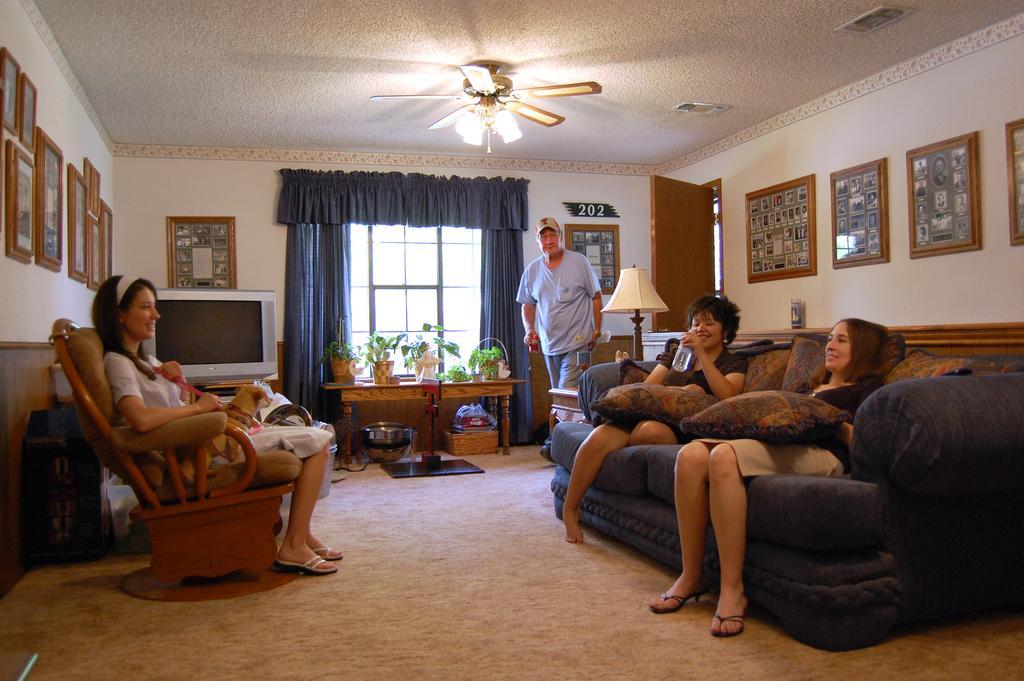How would you summarize this image in a sentence or two? As we can see in the image there is a white color wall, photo frames, fan, window, curtain and a table and few people sitting on sofas and there is a lamp over here. 